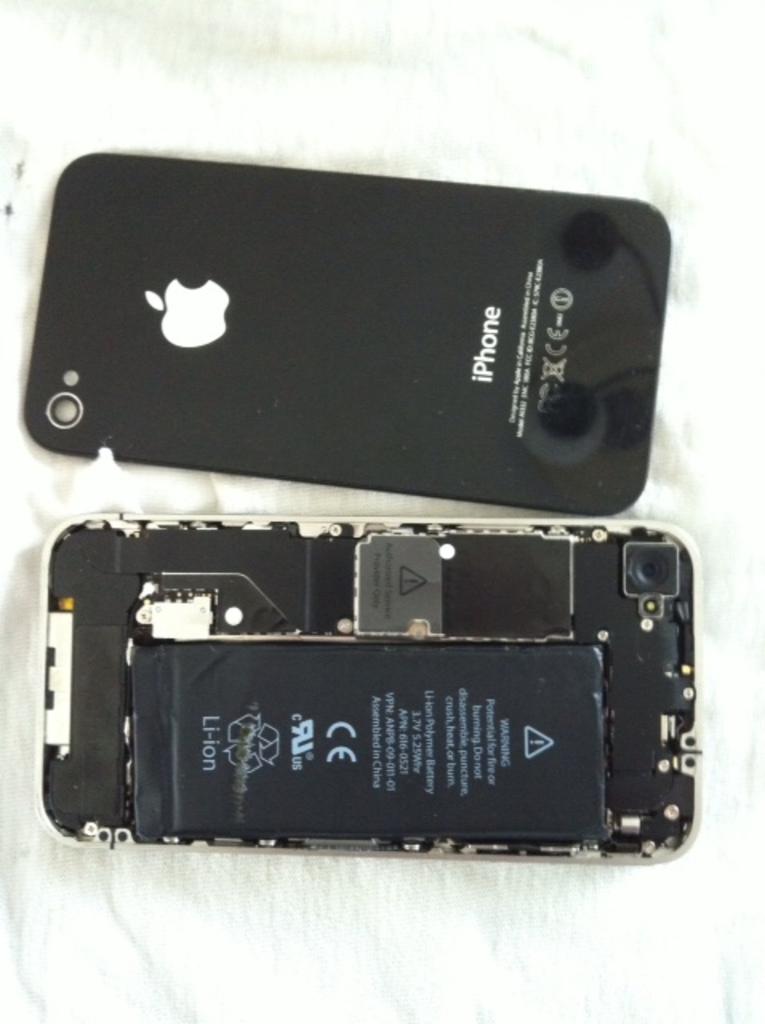What brand of phone is shown?
Provide a succinct answer. Iphone. What type of battery does the phone have?
Provide a succinct answer. Li-ion. 